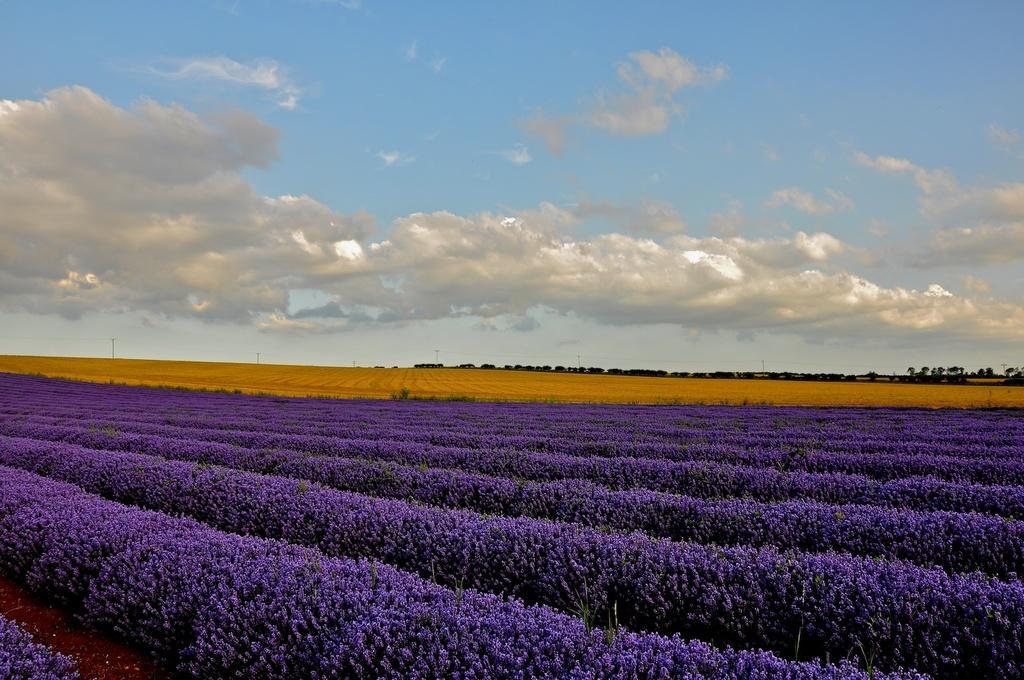Describe this image in one or two sentences. In this image we can see a group of flowers on the plants. On the backside we can see a group of trees, some poles and the sky. 